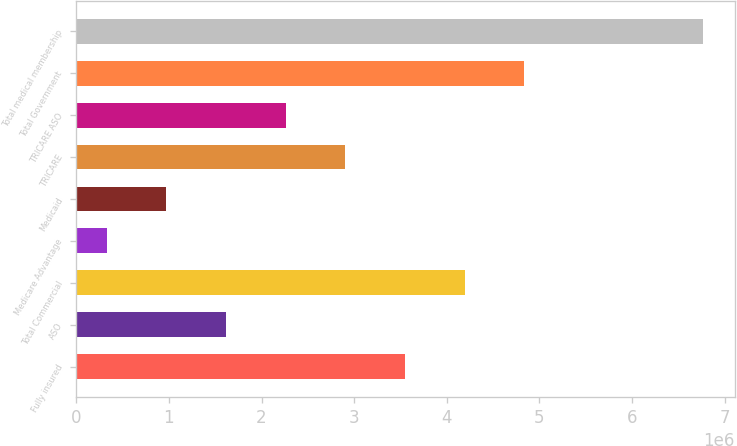<chart> <loc_0><loc_0><loc_500><loc_500><bar_chart><fcel>Fully insured<fcel>ASO<fcel>Total Commercial<fcel>Medicare Advantage<fcel>Medicaid<fcel>TRICARE<fcel>TRICARE ASO<fcel>Total Government<fcel>Total medical membership<nl><fcel>3.5491e+06<fcel>1.6168e+06<fcel>4.1932e+06<fcel>328600<fcel>972700<fcel>2.905e+06<fcel>2.2609e+06<fcel>4.8373e+06<fcel>6.7696e+06<nl></chart> 